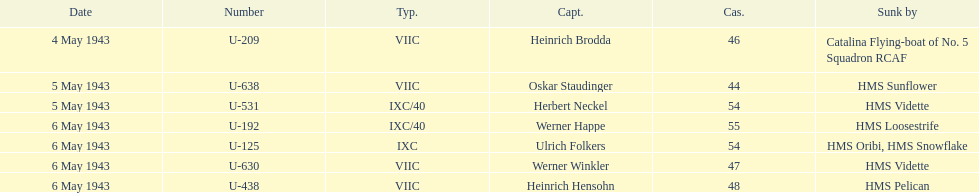Can you parse all the data within this table? {'header': ['Date', 'Number', 'Typ.', 'Capt.', 'Cas.', 'Sunk by'], 'rows': [['4 May 1943', 'U-209', 'VIIC', 'Heinrich Brodda', '46', 'Catalina Flying-boat of No. 5 Squadron RCAF'], ['5 May 1943', 'U-638', 'VIIC', 'Oskar Staudinger', '44', 'HMS Sunflower'], ['5 May 1943', 'U-531', 'IXC/40', 'Herbert Neckel', '54', 'HMS Vidette'], ['6 May 1943', 'U-192', 'IXC/40', 'Werner Happe', '55', 'HMS Loosestrife'], ['6 May 1943', 'U-125', 'IXC', 'Ulrich Folkers', '54', 'HMS Oribi, HMS Snowflake'], ['6 May 1943', 'U-630', 'VIIC', 'Werner Winkler', '47', 'HMS Vidette'], ['6 May 1943', 'U-438', 'VIIC', 'Heinrich Hensohn', '48', 'HMS Pelican']]} Which u-boat had more than 54 casualties? U-192. 